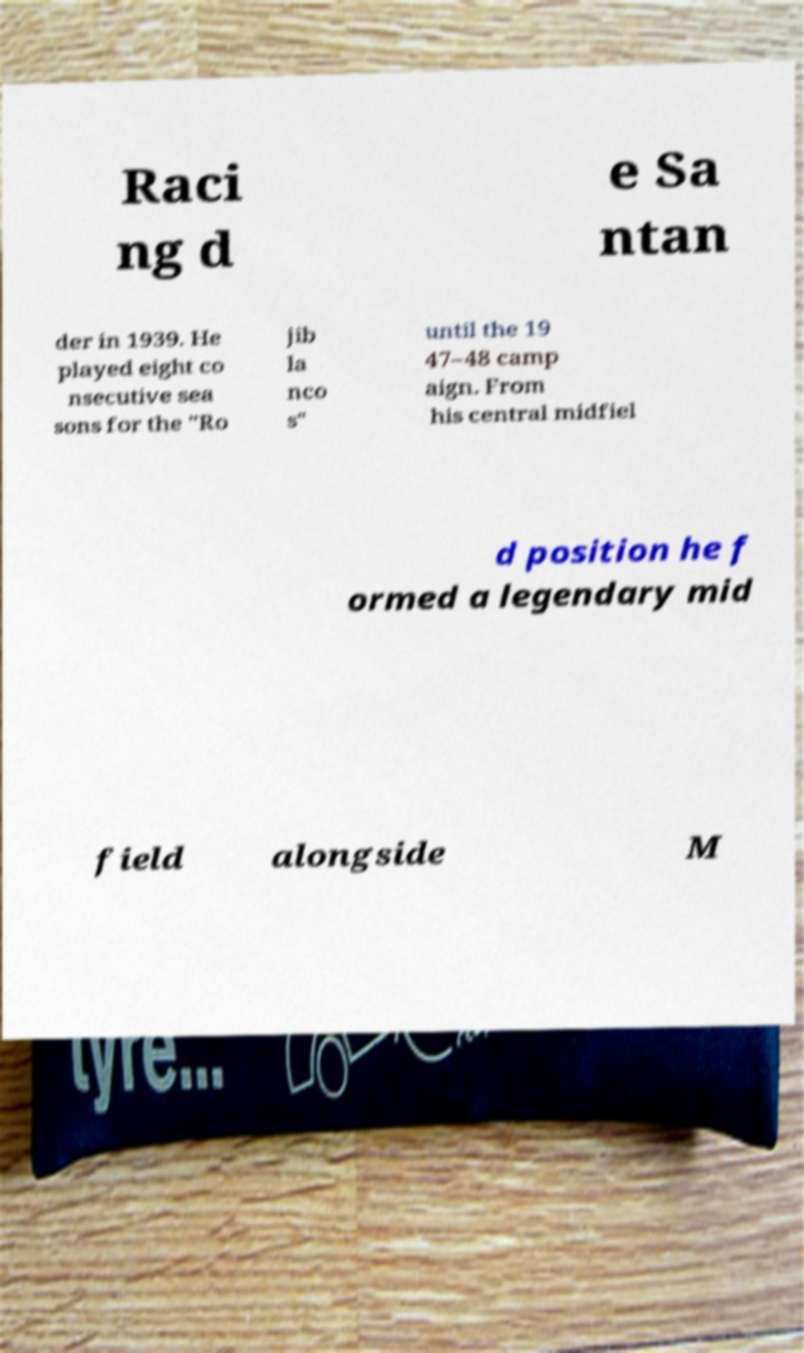Can you read and provide the text displayed in the image?This photo seems to have some interesting text. Can you extract and type it out for me? Raci ng d e Sa ntan der in 1939. He played eight co nsecutive sea sons for the "Ro jib la nco s" until the 19 47–48 camp aign. From his central midfiel d position he f ormed a legendary mid field alongside M 